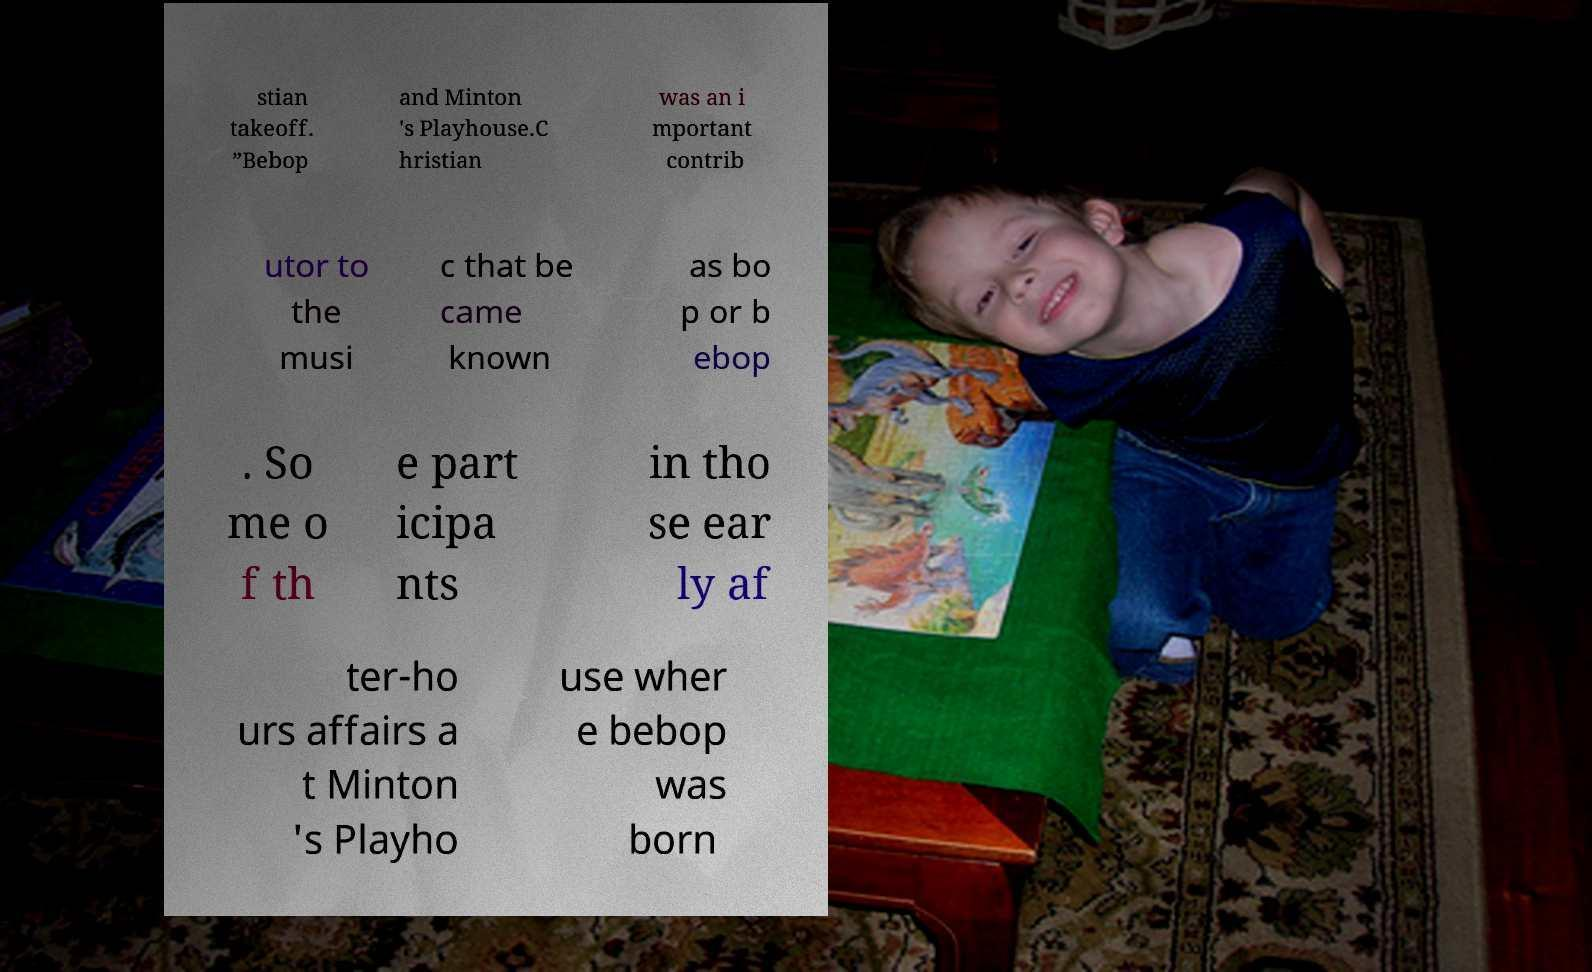For documentation purposes, I need the text within this image transcribed. Could you provide that? stian takeoff. ”Bebop and Minton 's Playhouse.C hristian was an i mportant contrib utor to the musi c that be came known as bo p or b ebop . So me o f th e part icipa nts in tho se ear ly af ter-ho urs affairs a t Minton 's Playho use wher e bebop was born 